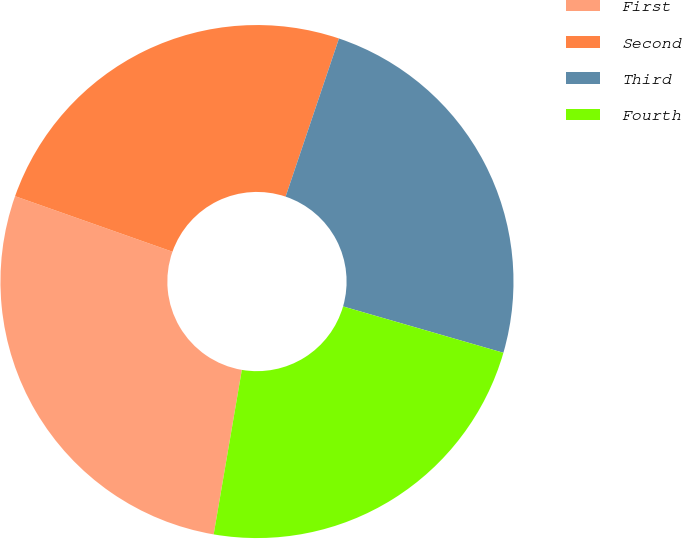Convert chart. <chart><loc_0><loc_0><loc_500><loc_500><pie_chart><fcel>First<fcel>Second<fcel>Third<fcel>Fourth<nl><fcel>27.7%<fcel>24.78%<fcel>24.3%<fcel>23.22%<nl></chart> 